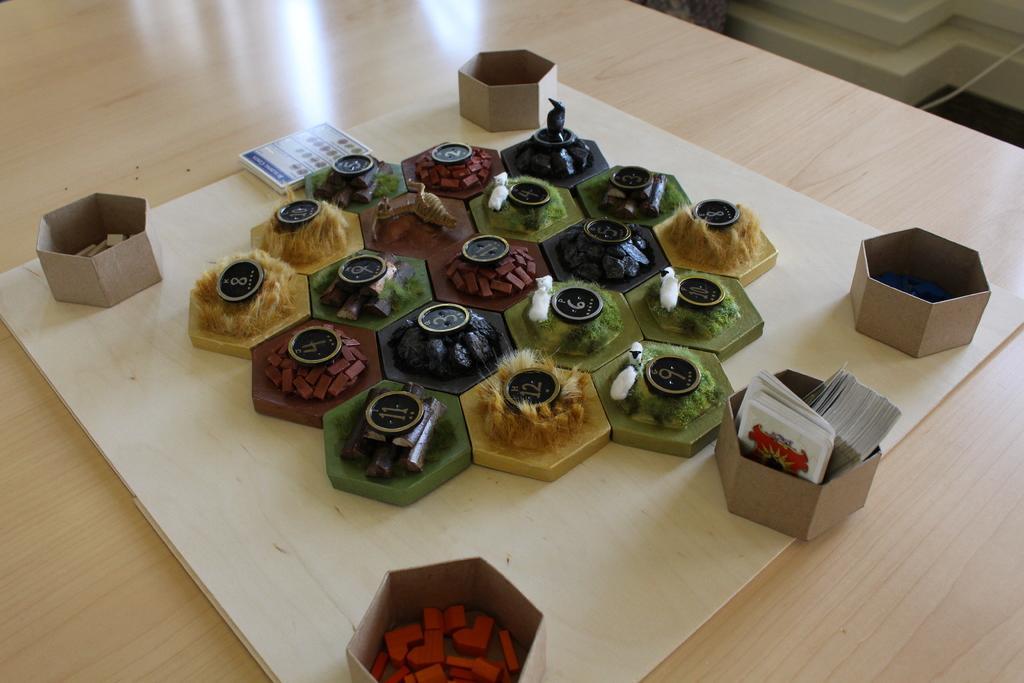Describe this image in one or two sentences. In this image we can see a cardboard with some things and there are some numbers on it and it looks like a board game. We can see the object placed on the surface which looks like a table. 